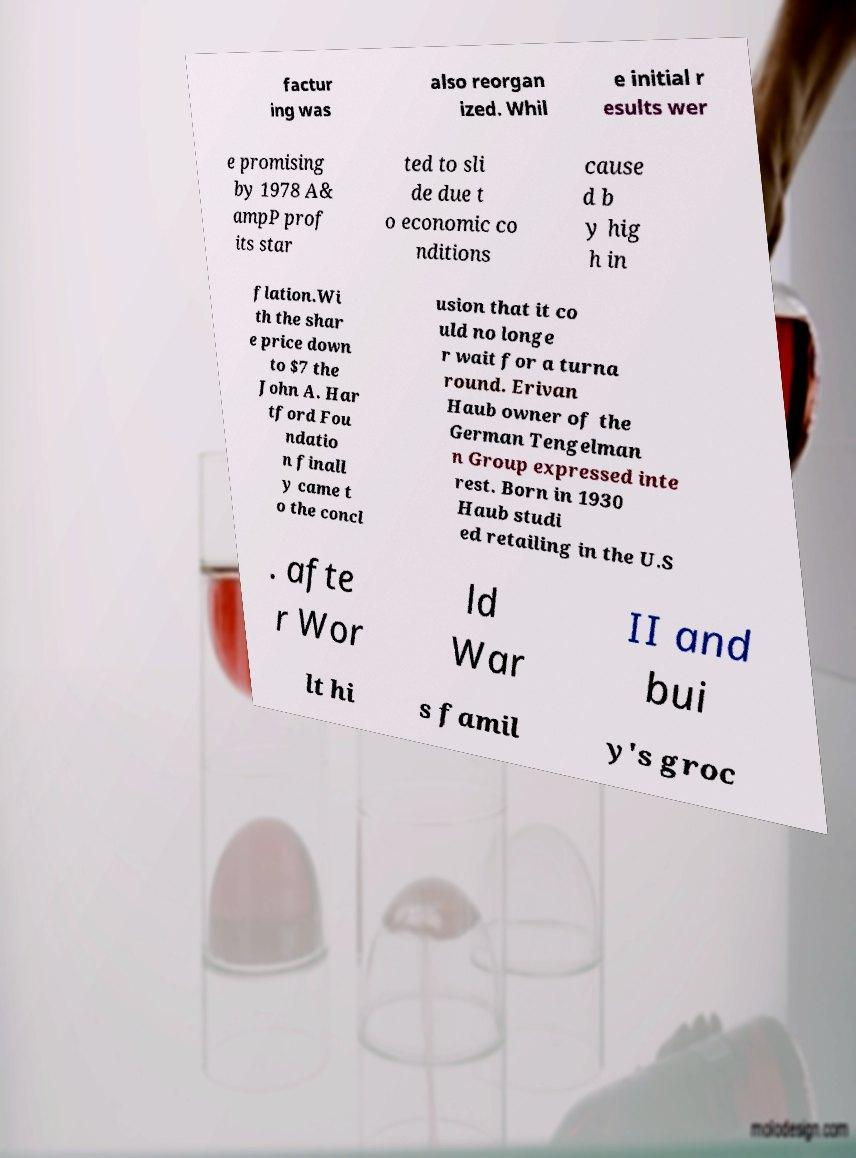Can you read and provide the text displayed in the image?This photo seems to have some interesting text. Can you extract and type it out for me? factur ing was also reorgan ized. Whil e initial r esults wer e promising by 1978 A& ampP prof its star ted to sli de due t o economic co nditions cause d b y hig h in flation.Wi th the shar e price down to $7 the John A. Har tford Fou ndatio n finall y came t o the concl usion that it co uld no longe r wait for a turna round. Erivan Haub owner of the German Tengelman n Group expressed inte rest. Born in 1930 Haub studi ed retailing in the U.S . afte r Wor ld War II and bui lt hi s famil y's groc 